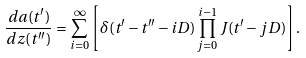<formula> <loc_0><loc_0><loc_500><loc_500>\frac { d a ( t ^ { \prime } ) } { d z ( t ^ { \prime \prime } ) } = \sum _ { i = 0 } ^ { \infty } \left [ \delta ( t ^ { \prime } - t ^ { \prime \prime } - i D ) \prod _ { j = 0 } ^ { i - 1 } J ( t ^ { \prime } - j D ) \right ] .</formula> 